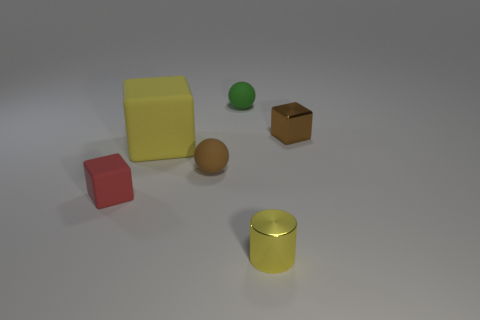Are the objects in the image real or are they computer-generated? The objects in the image appear to be computer-generated, showcasing a variety of geometric shapes such as cubes, cylinders, and a sphere with different colors and textures. What does the scene represent? The scene could represent a simple 3D modeling test environment often used in computer graphics to demonstrate lighting, shading, and texturing techniques. 